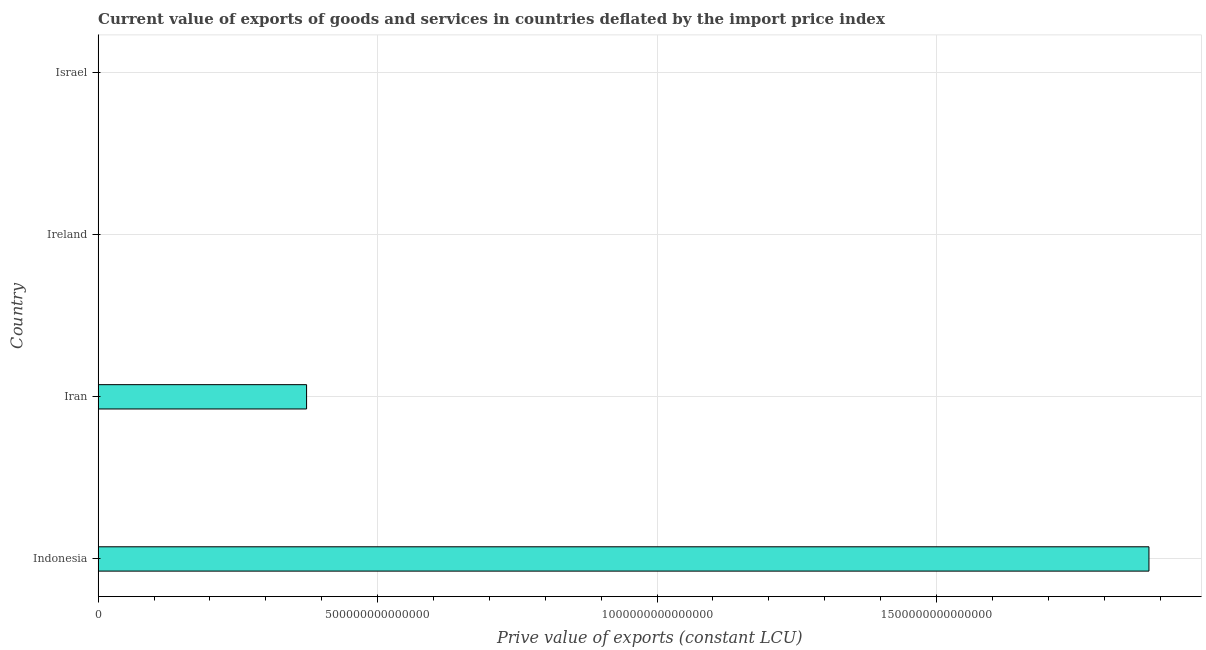Does the graph contain any zero values?
Provide a succinct answer. No. Does the graph contain grids?
Your answer should be compact. Yes. What is the title of the graph?
Give a very brief answer. Current value of exports of goods and services in countries deflated by the import price index. What is the label or title of the X-axis?
Offer a terse response. Prive value of exports (constant LCU). What is the label or title of the Y-axis?
Ensure brevity in your answer.  Country. What is the price value of exports in Ireland?
Offer a very short reply. 1.75e+11. Across all countries, what is the maximum price value of exports?
Provide a short and direct response. 1.88e+15. Across all countries, what is the minimum price value of exports?
Make the answer very short. 1.75e+11. In which country was the price value of exports maximum?
Give a very brief answer. Indonesia. In which country was the price value of exports minimum?
Make the answer very short. Ireland. What is the sum of the price value of exports?
Your answer should be very brief. 2.25e+15. What is the difference between the price value of exports in Iran and Israel?
Make the answer very short. 3.73e+14. What is the average price value of exports per country?
Offer a very short reply. 5.63e+14. What is the median price value of exports?
Provide a succinct answer. 1.87e+14. What is the ratio of the price value of exports in Indonesia to that in Israel?
Your answer should be compact. 5595.05. Is the difference between the price value of exports in Indonesia and Israel greater than the difference between any two countries?
Provide a succinct answer. No. What is the difference between the highest and the second highest price value of exports?
Offer a terse response. 1.51e+15. Is the sum of the price value of exports in Iran and Ireland greater than the maximum price value of exports across all countries?
Give a very brief answer. No. What is the difference between the highest and the lowest price value of exports?
Provide a succinct answer. 1.88e+15. In how many countries, is the price value of exports greater than the average price value of exports taken over all countries?
Your response must be concise. 1. How many bars are there?
Give a very brief answer. 4. Are all the bars in the graph horizontal?
Make the answer very short. Yes. How many countries are there in the graph?
Your answer should be very brief. 4. What is the difference between two consecutive major ticks on the X-axis?
Offer a terse response. 5.00e+14. What is the Prive value of exports (constant LCU) in Indonesia?
Offer a terse response. 1.88e+15. What is the Prive value of exports (constant LCU) in Iran?
Your answer should be very brief. 3.73e+14. What is the Prive value of exports (constant LCU) in Ireland?
Provide a short and direct response. 1.75e+11. What is the Prive value of exports (constant LCU) of Israel?
Provide a short and direct response. 3.36e+11. What is the difference between the Prive value of exports (constant LCU) in Indonesia and Iran?
Ensure brevity in your answer.  1.51e+15. What is the difference between the Prive value of exports (constant LCU) in Indonesia and Ireland?
Provide a succinct answer. 1.88e+15. What is the difference between the Prive value of exports (constant LCU) in Indonesia and Israel?
Offer a terse response. 1.88e+15. What is the difference between the Prive value of exports (constant LCU) in Iran and Ireland?
Offer a very short reply. 3.73e+14. What is the difference between the Prive value of exports (constant LCU) in Iran and Israel?
Provide a succinct answer. 3.73e+14. What is the difference between the Prive value of exports (constant LCU) in Ireland and Israel?
Your answer should be compact. -1.61e+11. What is the ratio of the Prive value of exports (constant LCU) in Indonesia to that in Iran?
Give a very brief answer. 5.04. What is the ratio of the Prive value of exports (constant LCU) in Indonesia to that in Ireland?
Provide a short and direct response. 1.08e+04. What is the ratio of the Prive value of exports (constant LCU) in Indonesia to that in Israel?
Provide a succinct answer. 5595.05. What is the ratio of the Prive value of exports (constant LCU) in Iran to that in Ireland?
Provide a succinct answer. 2135.72. What is the ratio of the Prive value of exports (constant LCU) in Iran to that in Israel?
Make the answer very short. 1109.96. What is the ratio of the Prive value of exports (constant LCU) in Ireland to that in Israel?
Offer a very short reply. 0.52. 